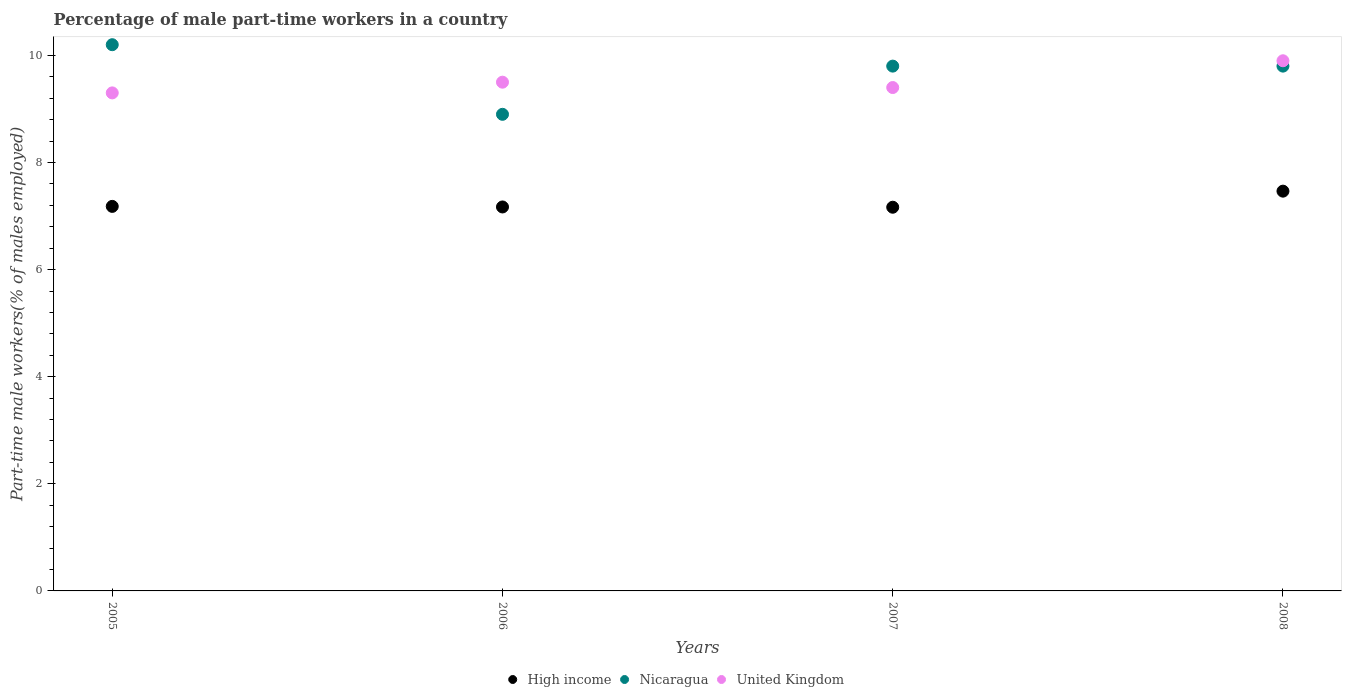What is the percentage of male part-time workers in High income in 2007?
Provide a short and direct response. 7.16. Across all years, what is the maximum percentage of male part-time workers in High income?
Your response must be concise. 7.47. Across all years, what is the minimum percentage of male part-time workers in United Kingdom?
Ensure brevity in your answer.  9.3. In which year was the percentage of male part-time workers in United Kingdom maximum?
Offer a very short reply. 2008. What is the total percentage of male part-time workers in United Kingdom in the graph?
Your answer should be compact. 38.1. What is the difference between the percentage of male part-time workers in United Kingdom in 2006 and that in 2007?
Offer a terse response. 0.1. What is the difference between the percentage of male part-time workers in United Kingdom in 2005 and the percentage of male part-time workers in Nicaragua in 2008?
Make the answer very short. -0.5. What is the average percentage of male part-time workers in High income per year?
Ensure brevity in your answer.  7.25. In the year 2007, what is the difference between the percentage of male part-time workers in High income and percentage of male part-time workers in United Kingdom?
Provide a short and direct response. -2.24. In how many years, is the percentage of male part-time workers in Nicaragua greater than 6.8 %?
Keep it short and to the point. 4. What is the ratio of the percentage of male part-time workers in High income in 2006 to that in 2008?
Your answer should be compact. 0.96. Is the difference between the percentage of male part-time workers in High income in 2007 and 2008 greater than the difference between the percentage of male part-time workers in United Kingdom in 2007 and 2008?
Your response must be concise. Yes. What is the difference between the highest and the second highest percentage of male part-time workers in United Kingdom?
Make the answer very short. 0.4. What is the difference between the highest and the lowest percentage of male part-time workers in United Kingdom?
Keep it short and to the point. 0.6. Is the percentage of male part-time workers in High income strictly greater than the percentage of male part-time workers in United Kingdom over the years?
Your response must be concise. No. Is the percentage of male part-time workers in United Kingdom strictly less than the percentage of male part-time workers in Nicaragua over the years?
Ensure brevity in your answer.  No. How many dotlines are there?
Make the answer very short. 3. How many years are there in the graph?
Offer a very short reply. 4. Are the values on the major ticks of Y-axis written in scientific E-notation?
Give a very brief answer. No. Does the graph contain grids?
Offer a terse response. No. Where does the legend appear in the graph?
Your answer should be compact. Bottom center. What is the title of the graph?
Offer a terse response. Percentage of male part-time workers in a country. Does "Madagascar" appear as one of the legend labels in the graph?
Keep it short and to the point. No. What is the label or title of the Y-axis?
Give a very brief answer. Part-time male workers(% of males employed). What is the Part-time male workers(% of males employed) of High income in 2005?
Your answer should be compact. 7.18. What is the Part-time male workers(% of males employed) of Nicaragua in 2005?
Provide a short and direct response. 10.2. What is the Part-time male workers(% of males employed) of United Kingdom in 2005?
Offer a very short reply. 9.3. What is the Part-time male workers(% of males employed) of High income in 2006?
Ensure brevity in your answer.  7.17. What is the Part-time male workers(% of males employed) in Nicaragua in 2006?
Your answer should be compact. 8.9. What is the Part-time male workers(% of males employed) in High income in 2007?
Keep it short and to the point. 7.16. What is the Part-time male workers(% of males employed) of Nicaragua in 2007?
Ensure brevity in your answer.  9.8. What is the Part-time male workers(% of males employed) in United Kingdom in 2007?
Your answer should be very brief. 9.4. What is the Part-time male workers(% of males employed) in High income in 2008?
Keep it short and to the point. 7.47. What is the Part-time male workers(% of males employed) in Nicaragua in 2008?
Keep it short and to the point. 9.8. What is the Part-time male workers(% of males employed) in United Kingdom in 2008?
Provide a short and direct response. 9.9. Across all years, what is the maximum Part-time male workers(% of males employed) in High income?
Keep it short and to the point. 7.47. Across all years, what is the maximum Part-time male workers(% of males employed) in Nicaragua?
Ensure brevity in your answer.  10.2. Across all years, what is the maximum Part-time male workers(% of males employed) of United Kingdom?
Your answer should be compact. 9.9. Across all years, what is the minimum Part-time male workers(% of males employed) in High income?
Provide a short and direct response. 7.16. Across all years, what is the minimum Part-time male workers(% of males employed) in Nicaragua?
Keep it short and to the point. 8.9. Across all years, what is the minimum Part-time male workers(% of males employed) of United Kingdom?
Make the answer very short. 9.3. What is the total Part-time male workers(% of males employed) in High income in the graph?
Offer a very short reply. 28.98. What is the total Part-time male workers(% of males employed) in Nicaragua in the graph?
Offer a terse response. 38.7. What is the total Part-time male workers(% of males employed) of United Kingdom in the graph?
Make the answer very short. 38.1. What is the difference between the Part-time male workers(% of males employed) of High income in 2005 and that in 2006?
Your answer should be very brief. 0.01. What is the difference between the Part-time male workers(% of males employed) of Nicaragua in 2005 and that in 2006?
Your answer should be compact. 1.3. What is the difference between the Part-time male workers(% of males employed) of United Kingdom in 2005 and that in 2006?
Provide a short and direct response. -0.2. What is the difference between the Part-time male workers(% of males employed) in High income in 2005 and that in 2007?
Ensure brevity in your answer.  0.02. What is the difference between the Part-time male workers(% of males employed) of Nicaragua in 2005 and that in 2007?
Ensure brevity in your answer.  0.4. What is the difference between the Part-time male workers(% of males employed) in High income in 2005 and that in 2008?
Your answer should be very brief. -0.28. What is the difference between the Part-time male workers(% of males employed) of Nicaragua in 2005 and that in 2008?
Offer a terse response. 0.4. What is the difference between the Part-time male workers(% of males employed) in United Kingdom in 2005 and that in 2008?
Ensure brevity in your answer.  -0.6. What is the difference between the Part-time male workers(% of males employed) in High income in 2006 and that in 2007?
Give a very brief answer. 0.01. What is the difference between the Part-time male workers(% of males employed) in United Kingdom in 2006 and that in 2007?
Your response must be concise. 0.1. What is the difference between the Part-time male workers(% of males employed) in High income in 2006 and that in 2008?
Offer a very short reply. -0.3. What is the difference between the Part-time male workers(% of males employed) in Nicaragua in 2006 and that in 2008?
Your response must be concise. -0.9. What is the difference between the Part-time male workers(% of males employed) of United Kingdom in 2006 and that in 2008?
Provide a succinct answer. -0.4. What is the difference between the Part-time male workers(% of males employed) of High income in 2007 and that in 2008?
Give a very brief answer. -0.3. What is the difference between the Part-time male workers(% of males employed) in Nicaragua in 2007 and that in 2008?
Your answer should be very brief. 0. What is the difference between the Part-time male workers(% of males employed) in United Kingdom in 2007 and that in 2008?
Give a very brief answer. -0.5. What is the difference between the Part-time male workers(% of males employed) of High income in 2005 and the Part-time male workers(% of males employed) of Nicaragua in 2006?
Your answer should be compact. -1.72. What is the difference between the Part-time male workers(% of males employed) of High income in 2005 and the Part-time male workers(% of males employed) of United Kingdom in 2006?
Make the answer very short. -2.32. What is the difference between the Part-time male workers(% of males employed) in Nicaragua in 2005 and the Part-time male workers(% of males employed) in United Kingdom in 2006?
Give a very brief answer. 0.7. What is the difference between the Part-time male workers(% of males employed) of High income in 2005 and the Part-time male workers(% of males employed) of Nicaragua in 2007?
Offer a very short reply. -2.62. What is the difference between the Part-time male workers(% of males employed) of High income in 2005 and the Part-time male workers(% of males employed) of United Kingdom in 2007?
Your answer should be compact. -2.22. What is the difference between the Part-time male workers(% of males employed) of Nicaragua in 2005 and the Part-time male workers(% of males employed) of United Kingdom in 2007?
Keep it short and to the point. 0.8. What is the difference between the Part-time male workers(% of males employed) in High income in 2005 and the Part-time male workers(% of males employed) in Nicaragua in 2008?
Provide a succinct answer. -2.62. What is the difference between the Part-time male workers(% of males employed) in High income in 2005 and the Part-time male workers(% of males employed) in United Kingdom in 2008?
Your answer should be very brief. -2.72. What is the difference between the Part-time male workers(% of males employed) of Nicaragua in 2005 and the Part-time male workers(% of males employed) of United Kingdom in 2008?
Offer a very short reply. 0.3. What is the difference between the Part-time male workers(% of males employed) of High income in 2006 and the Part-time male workers(% of males employed) of Nicaragua in 2007?
Keep it short and to the point. -2.63. What is the difference between the Part-time male workers(% of males employed) of High income in 2006 and the Part-time male workers(% of males employed) of United Kingdom in 2007?
Provide a short and direct response. -2.23. What is the difference between the Part-time male workers(% of males employed) of Nicaragua in 2006 and the Part-time male workers(% of males employed) of United Kingdom in 2007?
Give a very brief answer. -0.5. What is the difference between the Part-time male workers(% of males employed) of High income in 2006 and the Part-time male workers(% of males employed) of Nicaragua in 2008?
Make the answer very short. -2.63. What is the difference between the Part-time male workers(% of males employed) in High income in 2006 and the Part-time male workers(% of males employed) in United Kingdom in 2008?
Keep it short and to the point. -2.73. What is the difference between the Part-time male workers(% of males employed) of High income in 2007 and the Part-time male workers(% of males employed) of Nicaragua in 2008?
Your response must be concise. -2.63. What is the difference between the Part-time male workers(% of males employed) in High income in 2007 and the Part-time male workers(% of males employed) in United Kingdom in 2008?
Offer a very short reply. -2.73. What is the difference between the Part-time male workers(% of males employed) in Nicaragua in 2007 and the Part-time male workers(% of males employed) in United Kingdom in 2008?
Offer a very short reply. -0.1. What is the average Part-time male workers(% of males employed) of High income per year?
Provide a succinct answer. 7.25. What is the average Part-time male workers(% of males employed) in Nicaragua per year?
Keep it short and to the point. 9.68. What is the average Part-time male workers(% of males employed) in United Kingdom per year?
Your answer should be compact. 9.53. In the year 2005, what is the difference between the Part-time male workers(% of males employed) in High income and Part-time male workers(% of males employed) in Nicaragua?
Your response must be concise. -3.02. In the year 2005, what is the difference between the Part-time male workers(% of males employed) in High income and Part-time male workers(% of males employed) in United Kingdom?
Provide a short and direct response. -2.12. In the year 2006, what is the difference between the Part-time male workers(% of males employed) in High income and Part-time male workers(% of males employed) in Nicaragua?
Your answer should be very brief. -1.73. In the year 2006, what is the difference between the Part-time male workers(% of males employed) in High income and Part-time male workers(% of males employed) in United Kingdom?
Your answer should be very brief. -2.33. In the year 2007, what is the difference between the Part-time male workers(% of males employed) of High income and Part-time male workers(% of males employed) of Nicaragua?
Your response must be concise. -2.63. In the year 2007, what is the difference between the Part-time male workers(% of males employed) of High income and Part-time male workers(% of males employed) of United Kingdom?
Ensure brevity in your answer.  -2.23. In the year 2007, what is the difference between the Part-time male workers(% of males employed) of Nicaragua and Part-time male workers(% of males employed) of United Kingdom?
Keep it short and to the point. 0.4. In the year 2008, what is the difference between the Part-time male workers(% of males employed) of High income and Part-time male workers(% of males employed) of Nicaragua?
Provide a short and direct response. -2.33. In the year 2008, what is the difference between the Part-time male workers(% of males employed) in High income and Part-time male workers(% of males employed) in United Kingdom?
Provide a short and direct response. -2.43. What is the ratio of the Part-time male workers(% of males employed) of High income in 2005 to that in 2006?
Make the answer very short. 1. What is the ratio of the Part-time male workers(% of males employed) of Nicaragua in 2005 to that in 2006?
Ensure brevity in your answer.  1.15. What is the ratio of the Part-time male workers(% of males employed) of United Kingdom in 2005 to that in 2006?
Offer a terse response. 0.98. What is the ratio of the Part-time male workers(% of males employed) in High income in 2005 to that in 2007?
Your response must be concise. 1. What is the ratio of the Part-time male workers(% of males employed) of Nicaragua in 2005 to that in 2007?
Provide a short and direct response. 1.04. What is the ratio of the Part-time male workers(% of males employed) of United Kingdom in 2005 to that in 2007?
Offer a very short reply. 0.99. What is the ratio of the Part-time male workers(% of males employed) in High income in 2005 to that in 2008?
Ensure brevity in your answer.  0.96. What is the ratio of the Part-time male workers(% of males employed) of Nicaragua in 2005 to that in 2008?
Offer a terse response. 1.04. What is the ratio of the Part-time male workers(% of males employed) in United Kingdom in 2005 to that in 2008?
Make the answer very short. 0.94. What is the ratio of the Part-time male workers(% of males employed) in High income in 2006 to that in 2007?
Offer a very short reply. 1. What is the ratio of the Part-time male workers(% of males employed) in Nicaragua in 2006 to that in 2007?
Make the answer very short. 0.91. What is the ratio of the Part-time male workers(% of males employed) of United Kingdom in 2006 to that in 2007?
Offer a very short reply. 1.01. What is the ratio of the Part-time male workers(% of males employed) of High income in 2006 to that in 2008?
Provide a short and direct response. 0.96. What is the ratio of the Part-time male workers(% of males employed) of Nicaragua in 2006 to that in 2008?
Ensure brevity in your answer.  0.91. What is the ratio of the Part-time male workers(% of males employed) in United Kingdom in 2006 to that in 2008?
Your answer should be very brief. 0.96. What is the ratio of the Part-time male workers(% of males employed) of High income in 2007 to that in 2008?
Your answer should be compact. 0.96. What is the ratio of the Part-time male workers(% of males employed) in Nicaragua in 2007 to that in 2008?
Your answer should be compact. 1. What is the ratio of the Part-time male workers(% of males employed) in United Kingdom in 2007 to that in 2008?
Your answer should be compact. 0.95. What is the difference between the highest and the second highest Part-time male workers(% of males employed) in High income?
Make the answer very short. 0.28. What is the difference between the highest and the second highest Part-time male workers(% of males employed) in Nicaragua?
Your answer should be very brief. 0.4. What is the difference between the highest and the lowest Part-time male workers(% of males employed) in High income?
Your answer should be compact. 0.3. 